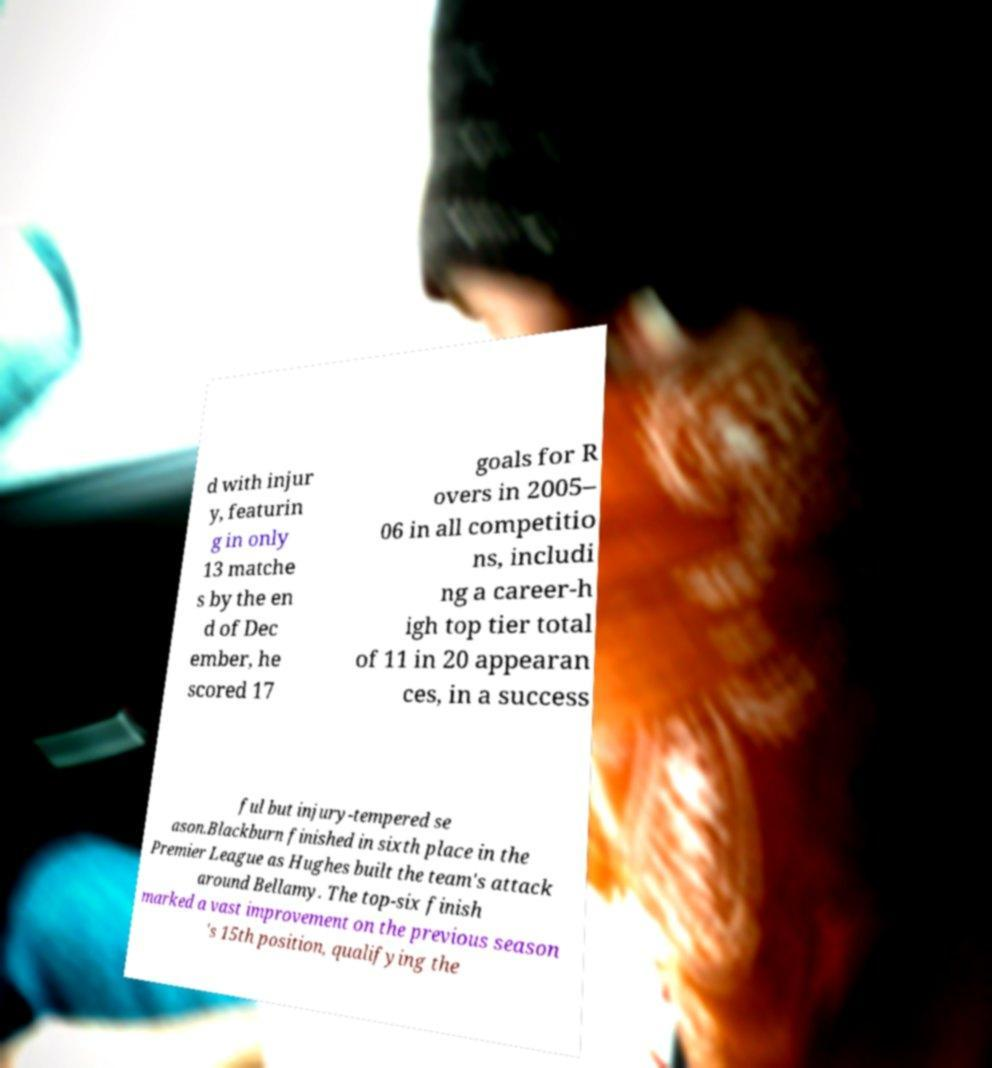I need the written content from this picture converted into text. Can you do that? d with injur y, featurin g in only 13 matche s by the en d of Dec ember, he scored 17 goals for R overs in 2005– 06 in all competitio ns, includi ng a career-h igh top tier total of 11 in 20 appearan ces, in a success ful but injury-tempered se ason.Blackburn finished in sixth place in the Premier League as Hughes built the team's attack around Bellamy. The top-six finish marked a vast improvement on the previous season 's 15th position, qualifying the 